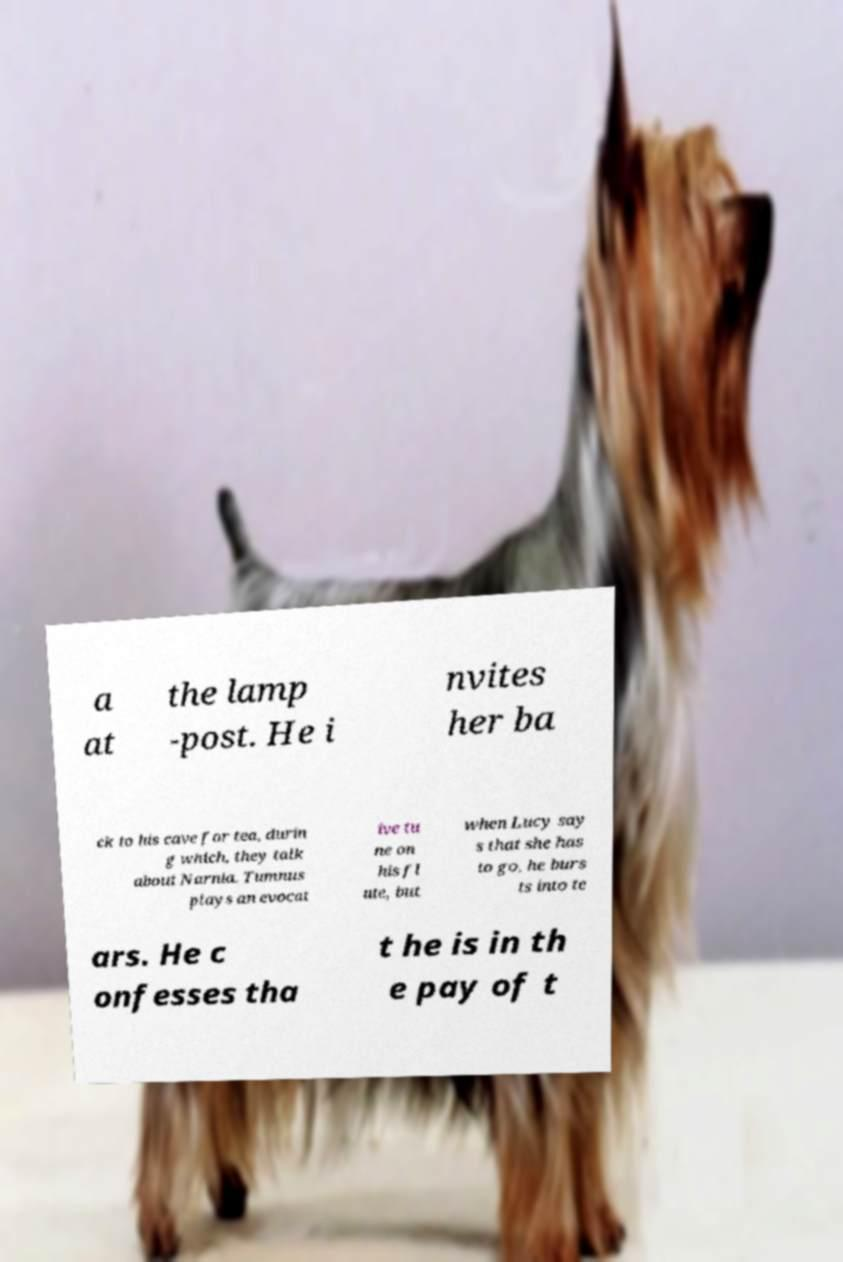There's text embedded in this image that I need extracted. Can you transcribe it verbatim? a at the lamp -post. He i nvites her ba ck to his cave for tea, durin g which, they talk about Narnia. Tumnus plays an evocat ive tu ne on his fl ute, but when Lucy say s that she has to go, he burs ts into te ars. He c onfesses tha t he is in th e pay of t 